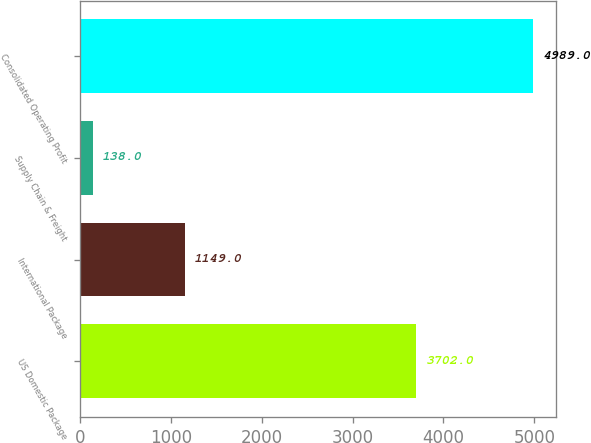Convert chart. <chart><loc_0><loc_0><loc_500><loc_500><bar_chart><fcel>US Domestic Package<fcel>International Package<fcel>Supply Chain & Freight<fcel>Consolidated Operating Profit<nl><fcel>3702<fcel>1149<fcel>138<fcel>4989<nl></chart> 